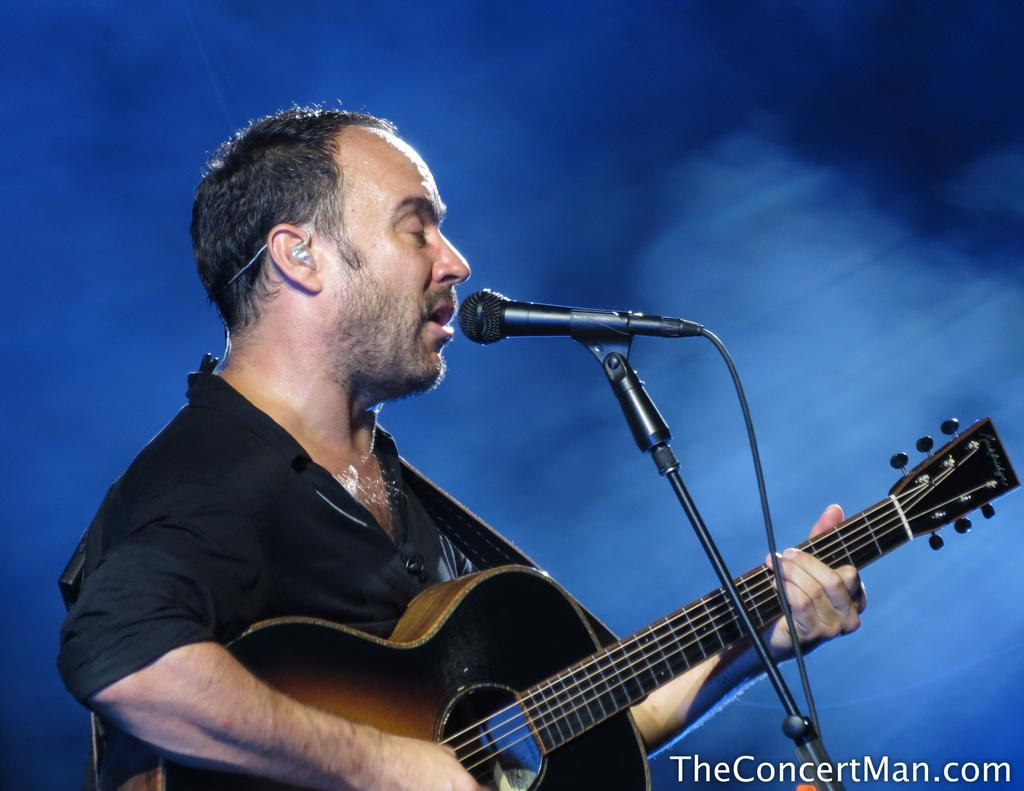What is the man in the image doing? The man is playing a guitar and singing into a microphone. What instrument is the man playing in the image? The man is playing a guitar. What is the man using to amplify his voice in the image? The man is using a microphone to amplify his voice. What type of pets does the man have in the image? There are no pets visible in the image. What day of the week is it in the image? The day of the week is not mentioned or depicted in the image. 